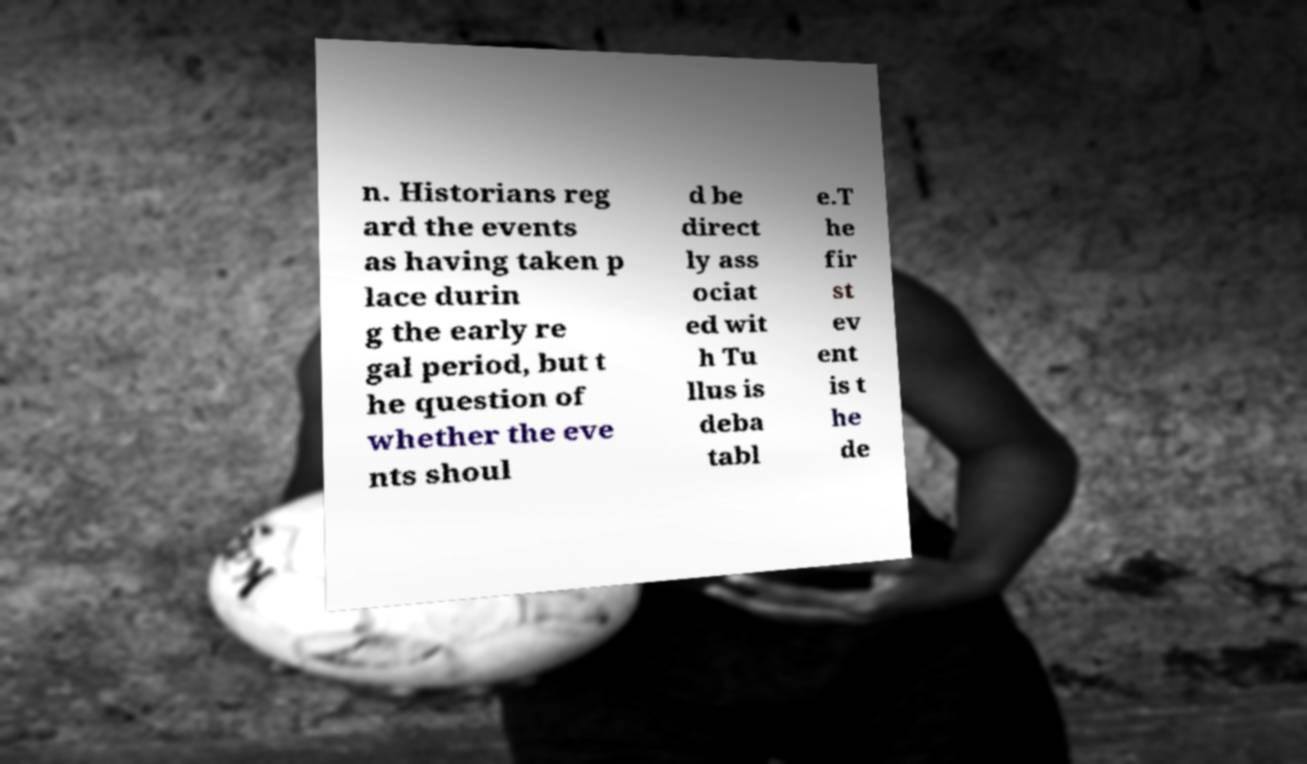Please read and relay the text visible in this image. What does it say? n. Historians reg ard the events as having taken p lace durin g the early re gal period, but t he question of whether the eve nts shoul d be direct ly ass ociat ed wit h Tu llus is deba tabl e.T he fir st ev ent is t he de 